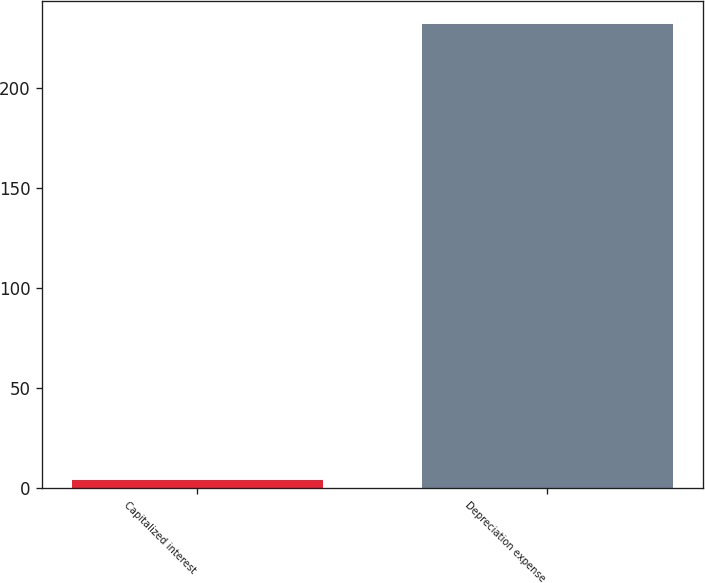Convert chart. <chart><loc_0><loc_0><loc_500><loc_500><bar_chart><fcel>Capitalized interest<fcel>Depreciation expense<nl><fcel>4<fcel>232<nl></chart> 